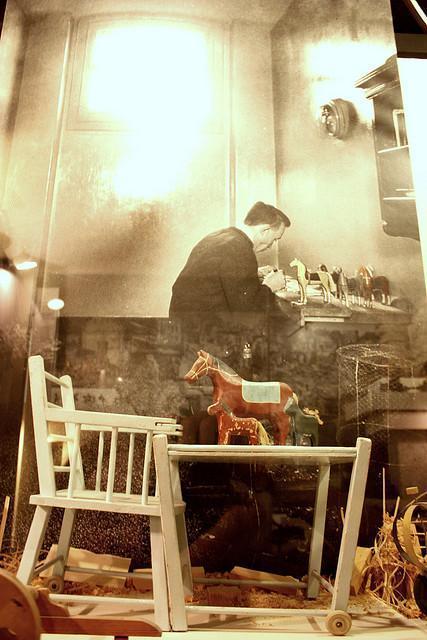How many chairs are pictured?
Give a very brief answer. 1. 